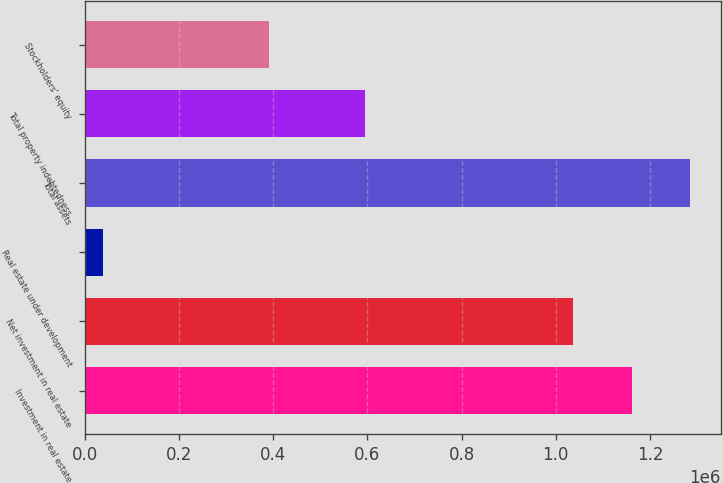Convert chart to OTSL. <chart><loc_0><loc_0><loc_500><loc_500><bar_chart><fcel>Investment in real estate<fcel>Net investment in real estate<fcel>Real estate under development<fcel>Total assets<fcel>Total property indebtedness<fcel>Stockholders' equity<nl><fcel>1.16127e+06<fcel>1.03691e+06<fcel>38231<fcel>1.28563e+06<fcel>595535<fcel>391675<nl></chart> 